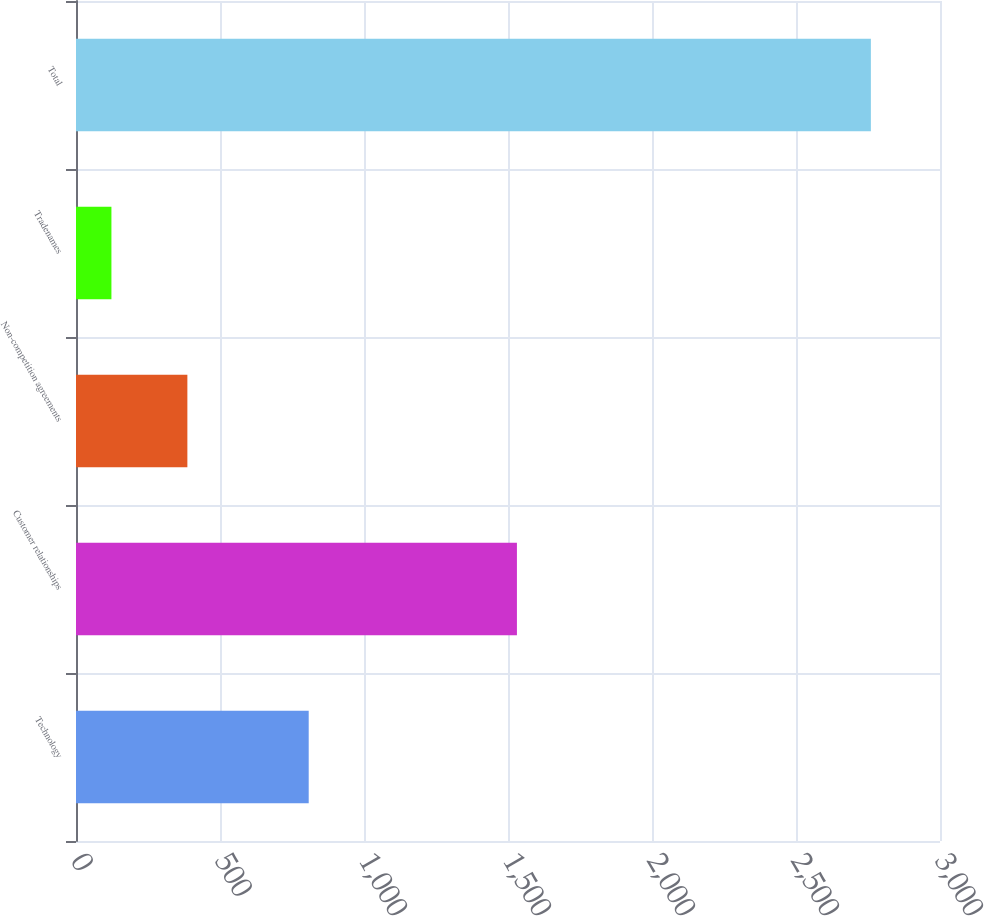Convert chart to OTSL. <chart><loc_0><loc_0><loc_500><loc_500><bar_chart><fcel>Technology<fcel>Customer relationships<fcel>Non-competition agreements<fcel>Tradenames<fcel>Total<nl><fcel>808<fcel>1531<fcel>386.7<fcel>123<fcel>2760<nl></chart> 